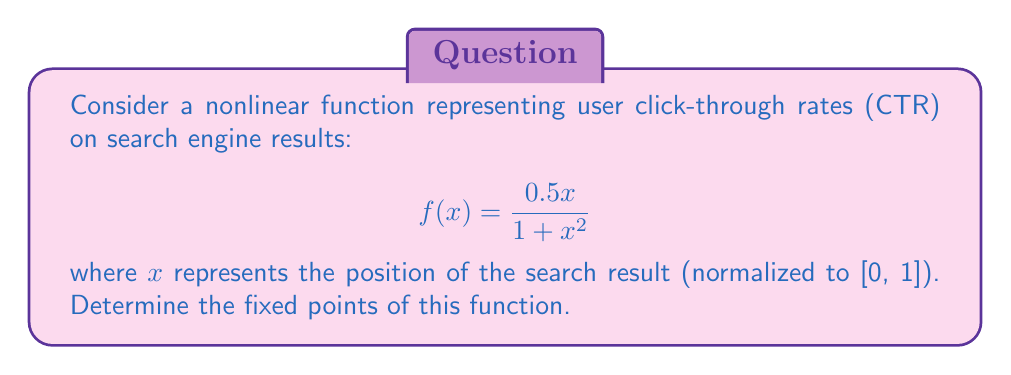What is the answer to this math problem? To find the fixed points of the function, we need to solve the equation $f(x) = x$. This means:

1) Set up the equation:
   $$\frac{0.5x}{1 + x^2} = x$$

2) Multiply both sides by $(1 + x^2)$:
   $$0.5x = x(1 + x^2)$$

3) Expand the right side:
   $$0.5x = x + x^3$$

4) Subtract $0.5x$ from both sides:
   $$0 = 0.5x + x^3$$

5) Factor out $x$:
   $$0 = x(0.5 + x^2)$$

6) Set each factor to zero and solve:
   a) $x = 0$
   b) $0.5 + x^2 = 0$
      $x^2 = -0.5$
      $x = \pm i\sqrt{0.5}$

7) Since we're dealing with real-valued positions, we discard the complex solutions.

Therefore, the only fixed point of this function is $x = 0$.
Answer: $x = 0$ 